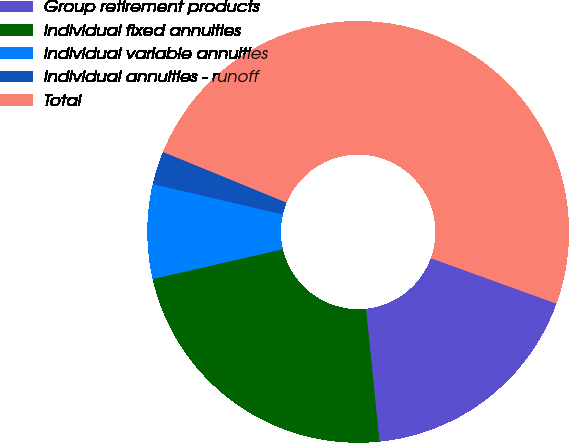Convert chart to OTSL. <chart><loc_0><loc_0><loc_500><loc_500><pie_chart><fcel>Group retirement products<fcel>Individual fixed annuities<fcel>Individual variable annuities<fcel>Individual annuities - runoff<fcel>Total<nl><fcel>17.87%<fcel>23.02%<fcel>7.23%<fcel>2.55%<fcel>49.32%<nl></chart> 